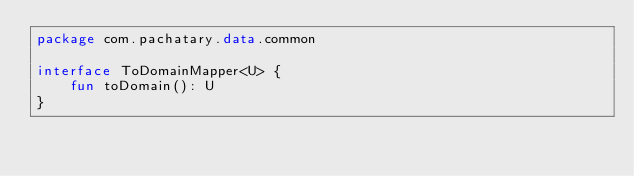<code> <loc_0><loc_0><loc_500><loc_500><_Kotlin_>package com.pachatary.data.common

interface ToDomainMapper<U> {
    fun toDomain(): U
}
</code> 